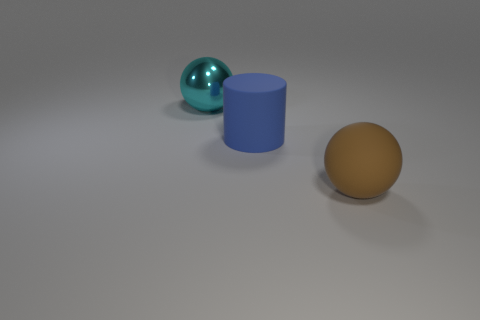Are there fewer large cyan metal spheres in front of the cyan thing than large cyan metal balls in front of the big rubber cylinder?
Your response must be concise. No. There is a large thing right of the big matte thing to the left of the brown rubber thing; are there any matte spheres to the left of it?
Give a very brief answer. No. There is a rubber object behind the large rubber sphere; is it the same shape as the large cyan object that is to the left of the brown rubber object?
Provide a succinct answer. No. There is a cyan sphere that is the same size as the rubber cylinder; what is its material?
Offer a terse response. Metal. Do the sphere to the left of the brown rubber object and the ball on the right side of the big blue thing have the same material?
Offer a terse response. No. What shape is the brown object that is the same size as the blue object?
Your answer should be compact. Sphere. How many other things are the same color as the big matte sphere?
Provide a short and direct response. 0. The ball left of the large blue rubber thing is what color?
Ensure brevity in your answer.  Cyan. How many other things are there of the same material as the blue object?
Offer a terse response. 1. Is the number of cylinders to the right of the big brown thing greater than the number of large cyan shiny balls on the left side of the cyan sphere?
Provide a short and direct response. No. 